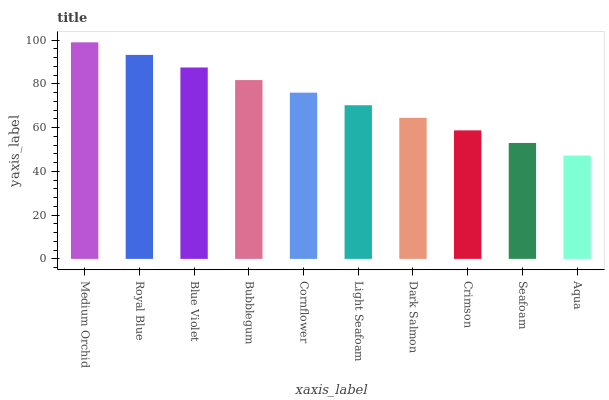Is Aqua the minimum?
Answer yes or no. Yes. Is Medium Orchid the maximum?
Answer yes or no. Yes. Is Royal Blue the minimum?
Answer yes or no. No. Is Royal Blue the maximum?
Answer yes or no. No. Is Medium Orchid greater than Royal Blue?
Answer yes or no. Yes. Is Royal Blue less than Medium Orchid?
Answer yes or no. Yes. Is Royal Blue greater than Medium Orchid?
Answer yes or no. No. Is Medium Orchid less than Royal Blue?
Answer yes or no. No. Is Cornflower the high median?
Answer yes or no. Yes. Is Light Seafoam the low median?
Answer yes or no. Yes. Is Crimson the high median?
Answer yes or no. No. Is Blue Violet the low median?
Answer yes or no. No. 